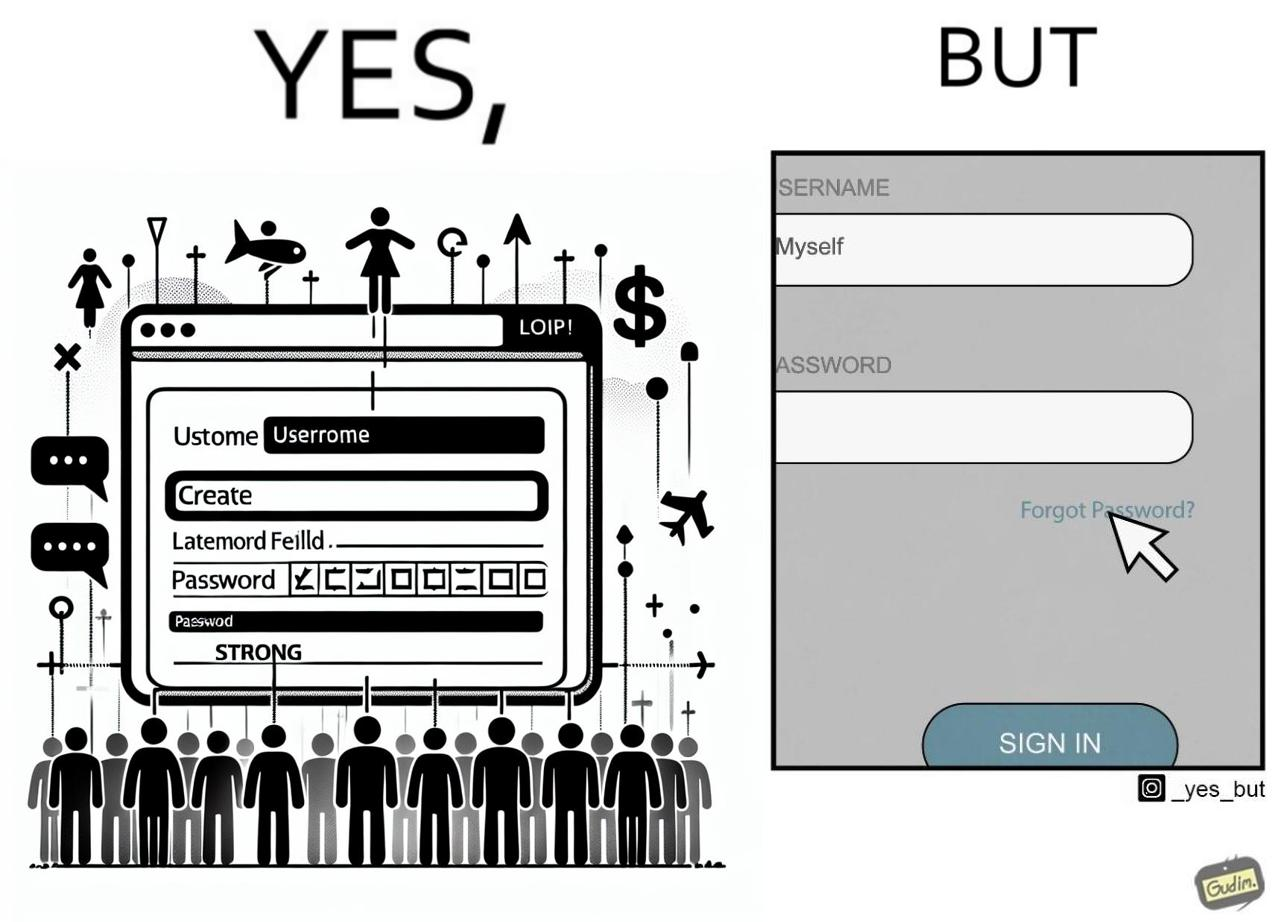Why is this image considered satirical? The image is ironic, because people set such a strong passwords for their accounts that they even forget the password and need to reset them 